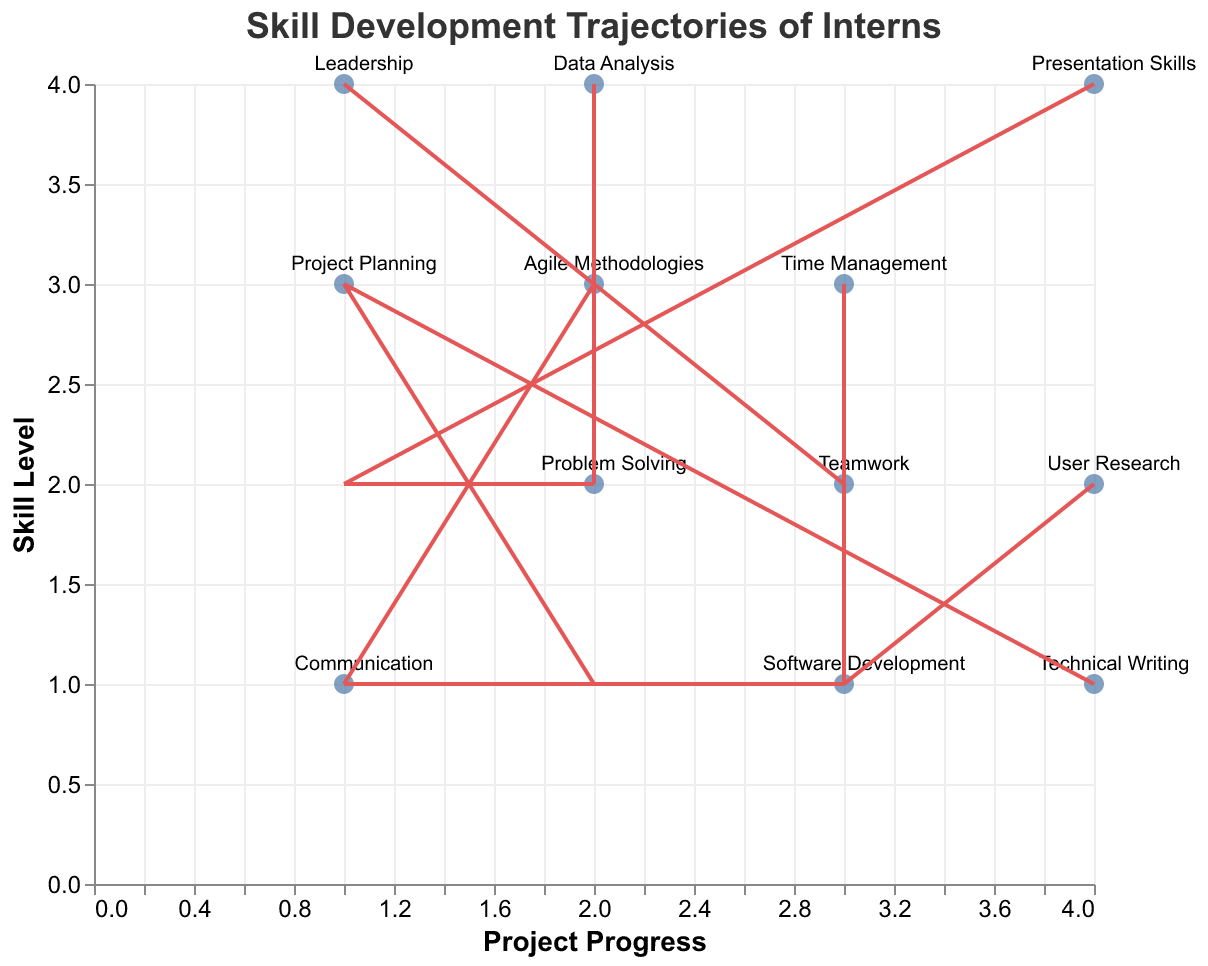what is the title of the figure? The title of the figure is displayed at the top center.
Answer: Skill Development Trajectories of Interns How many data points are represented in the plot? Each set of (x, y) coordinates represents a data point, and there are 12 unique data points listed in the data.
Answer: 12 Which skill shows the highest increase in skill level as the project progresses? The highest increase in skill level is shown by the largest vertical component (v) in the plot. "Teamwork" has a vertical component of 3, which is the highest among the skills.
Answer: Teamwork Between "Communication" and "Technical Writing," which skill starts at a higher initial skill level? "Communication" and "Technical Writing" have initial skill levels represented by their y-coordinates. Communication starts at y = 1 and Technical Writing starts at y = 1. Since they are equal, neither starts higher.
Answer: Neither starts higher Which skill has the least improvement in both aspects (skill level and project progress)? The skill with the least improvement will have the smallest overall (u, v) values. "Software Development" has (u, v) values of (1, 1), which is the smallest combined improvement.
Answer: Software Development Compare the skill improvement in "Leadership" and "Problem Solving" in terms of project progress. Compare the u values for "Leadership" and "Problem Solving" to determine which has more project progress. "Leadership" has u = 2 and "Problem Solving" has u = 1, so "Leadership" shows more improvement.
Answer: Leadership Considering skills that start at a y-coordinate of 3, which skill has the largest horizontal improvement? Skills that start at y = 3 are "Data Analysis" and "Leadership". "Data Analysis" has a horizontal improvement (u) of 2, whereas "Leadership" has a horizontal improvement of 2. Both show the same horizontal improvement.
Answer: Both show the same horizontal improvement Which skill showed a greater improvement in skill level, "Leadership" or "Communication"? To compare skill level improvement, compare the v values for these skills. "Leadership" has v = 3, and "Communication" also has v = 3, so their improvements are equal.
Answer: Equal Identify the skill which progresses one step in both project progress and skill level simultaneously. The skill that has both u and v values equal to 1 will meet this condition. "Software Development" has (u, v) values of (1, 1).
Answer: Software Development 